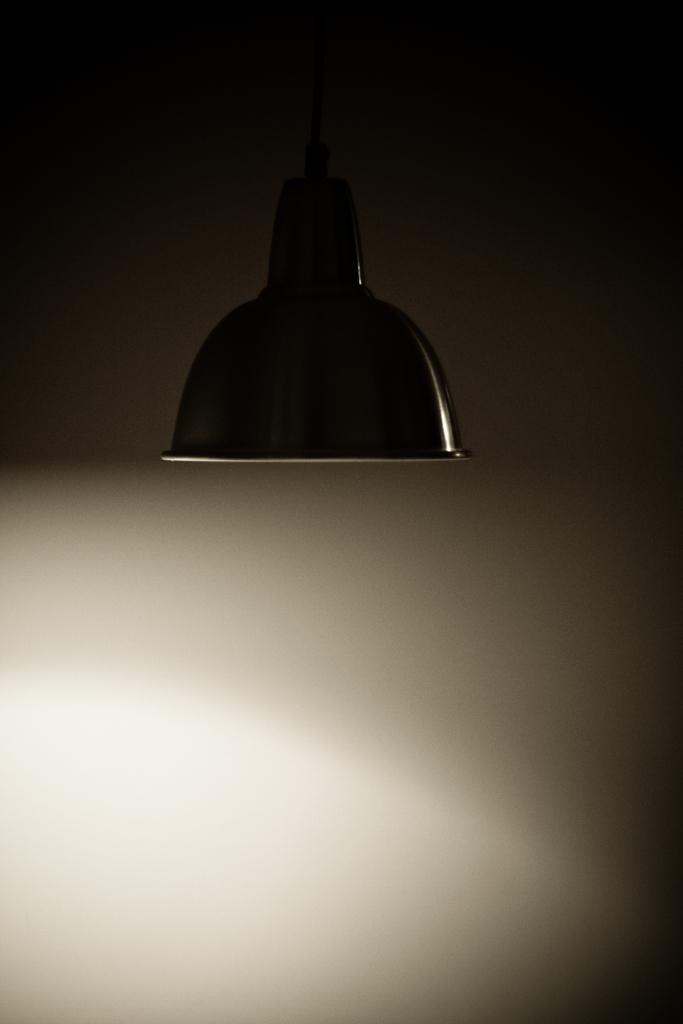What object is the main focus of the image? The main focus of the image is a bulb cover. What can be seen in the background of the image? There is a white color wall in the background of the image. How would you describe the lighting in the image? The image appears to be slightly dark. In which direction is the girl facing in the image? There is no girl present in the image; it only features a bulb cover and a white color wall in the background. 